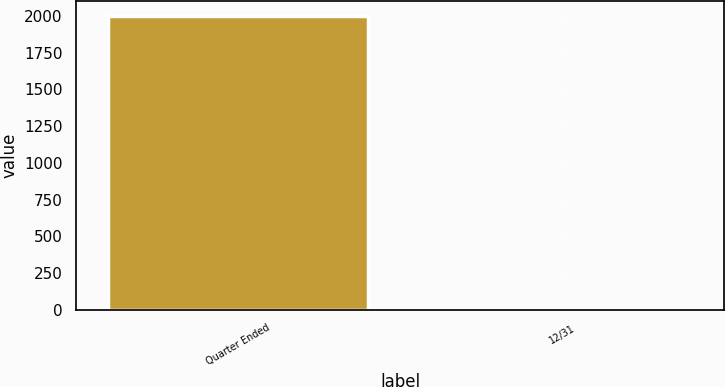<chart> <loc_0><loc_0><loc_500><loc_500><bar_chart><fcel>Quarter Ended<fcel>12/31<nl><fcel>2002<fcel>0.77<nl></chart> 